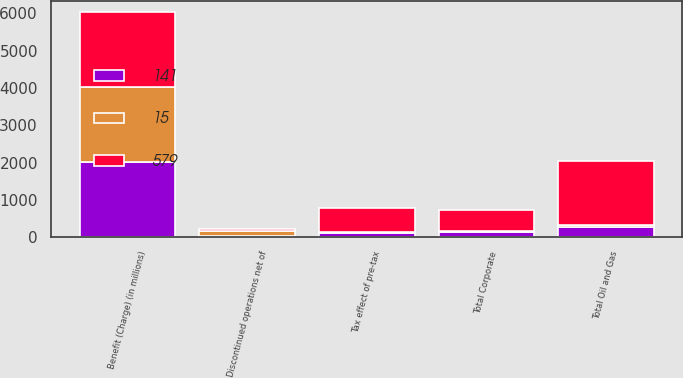<chart> <loc_0><loc_0><loc_500><loc_500><stacked_bar_chart><ecel><fcel>Benefit (Charge) (in millions)<fcel>Total Oil and Gas<fcel>Tax effect of pre-tax<fcel>Discontinued operations net of<fcel>Total Corporate<nl><fcel>579<fcel>2012<fcel>1731<fcel>636<fcel>37<fcel>579<nl><fcel>15<fcel>2011<fcel>42<fcel>50<fcel>131<fcel>15<nl><fcel>141<fcel>2010<fcel>275<fcel>100<fcel>39<fcel>141<nl></chart> 